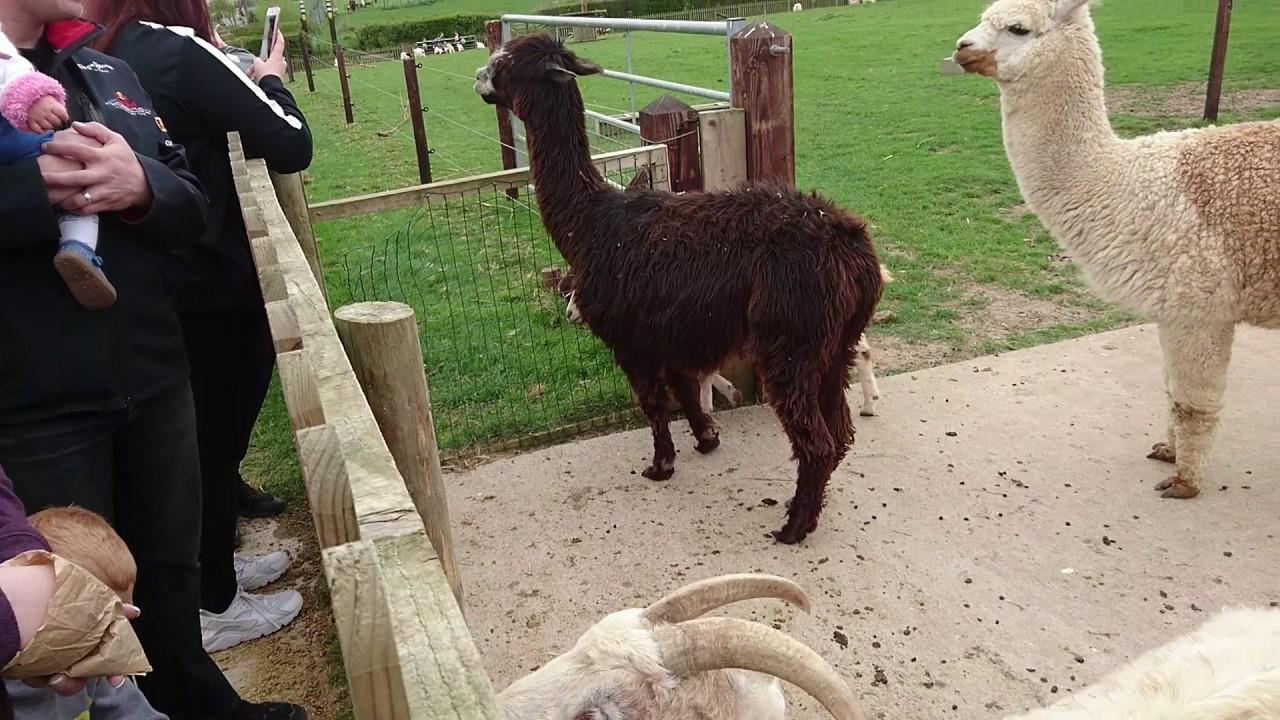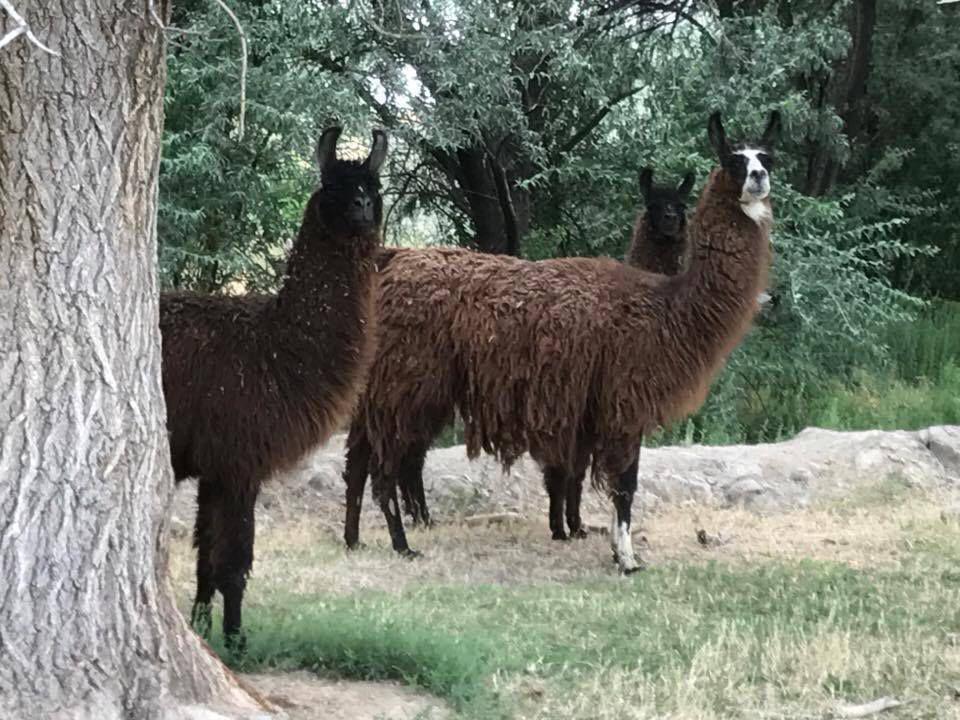The first image is the image on the left, the second image is the image on the right. Considering the images on both sides, is "An image contains two llamas standing in front of a fence and near at least one white animal that is not a llama." valid? Answer yes or no. Yes. The first image is the image on the left, the second image is the image on the right. Assess this claim about the two images: "There is a single llama in one image.". Correct or not? Answer yes or no. No. 